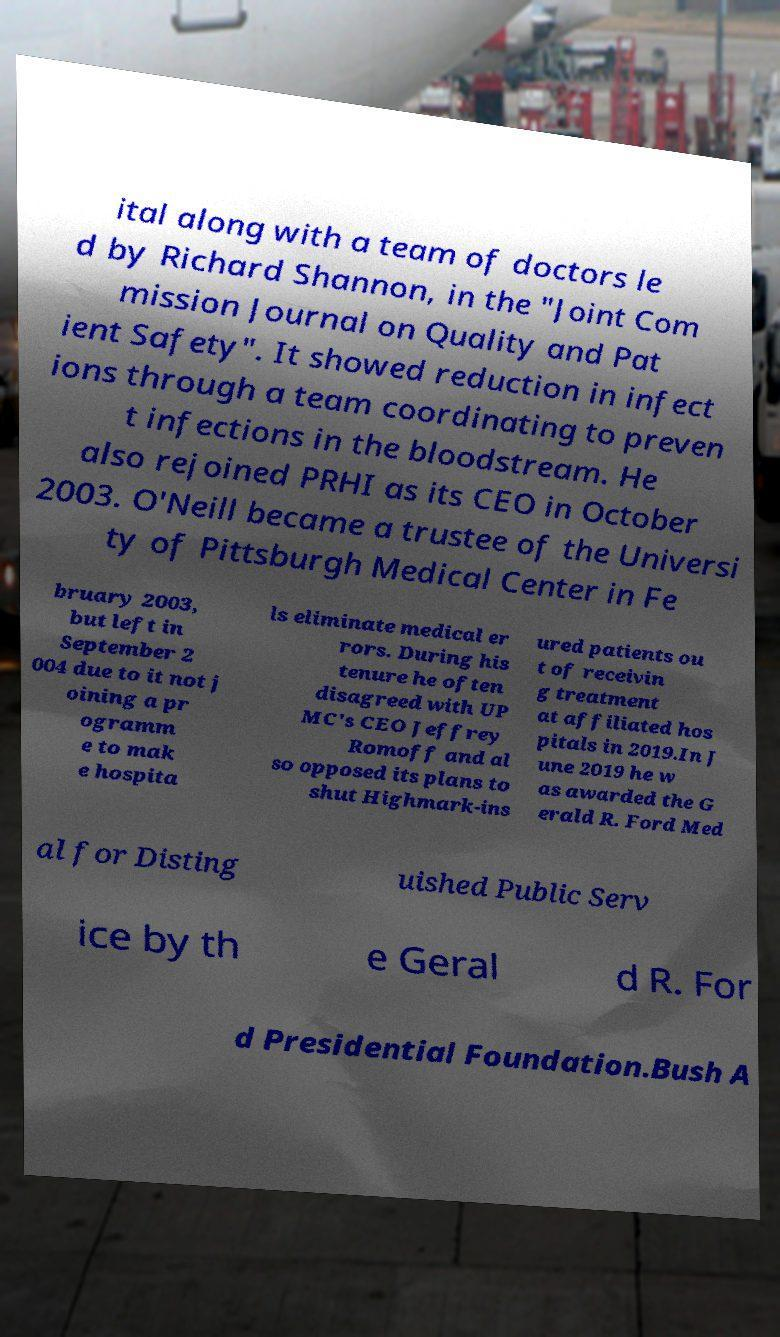What messages or text are displayed in this image? I need them in a readable, typed format. ital along with a team of doctors le d by Richard Shannon, in the "Joint Com mission Journal on Quality and Pat ient Safety". It showed reduction in infect ions through a team coordinating to preven t infections in the bloodstream. He also rejoined PRHI as its CEO in October 2003. O'Neill became a trustee of the Universi ty of Pittsburgh Medical Center in Fe bruary 2003, but left in September 2 004 due to it not j oining a pr ogramm e to mak e hospita ls eliminate medical er rors. During his tenure he often disagreed with UP MC's CEO Jeffrey Romoff and al so opposed its plans to shut Highmark-ins ured patients ou t of receivin g treatment at affiliated hos pitals in 2019.In J une 2019 he w as awarded the G erald R. Ford Med al for Disting uished Public Serv ice by th e Geral d R. For d Presidential Foundation.Bush A 